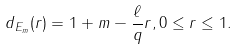<formula> <loc_0><loc_0><loc_500><loc_500>d _ { E _ { m } } ( r ) = 1 + m - \frac { \ell } { q } r , 0 \leq r \leq 1 .</formula> 